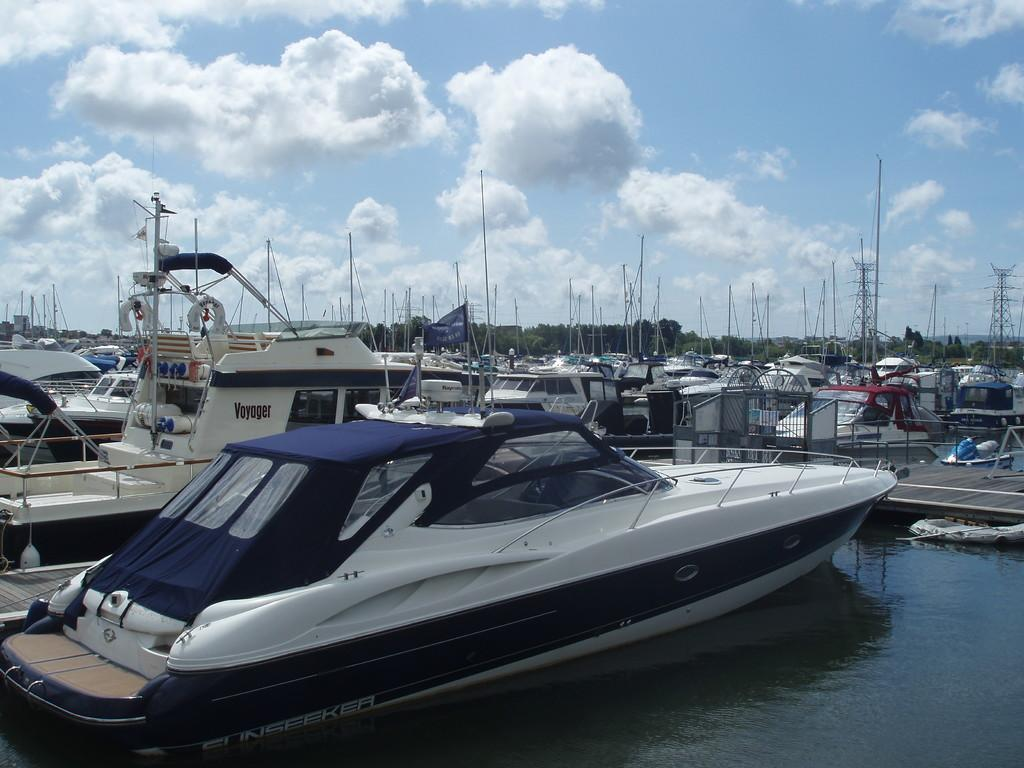What is floating on the surface of the water in the image? There are boats on the surface of the water in the image. What structure can be seen on the right side of the image? There is a bridge on the right side of the image. What type of infrastructure is present in the image? There are transmission towers in the image. What can be seen in the background of the image? Trees are present in the background of the image. What is visible at the top of the image? The sky is visible at the top of the image. Where is the sofa located in the image? There is no sofa present in the image. Can you describe the boy and his father in the image? There is no boy or father present in the image. 